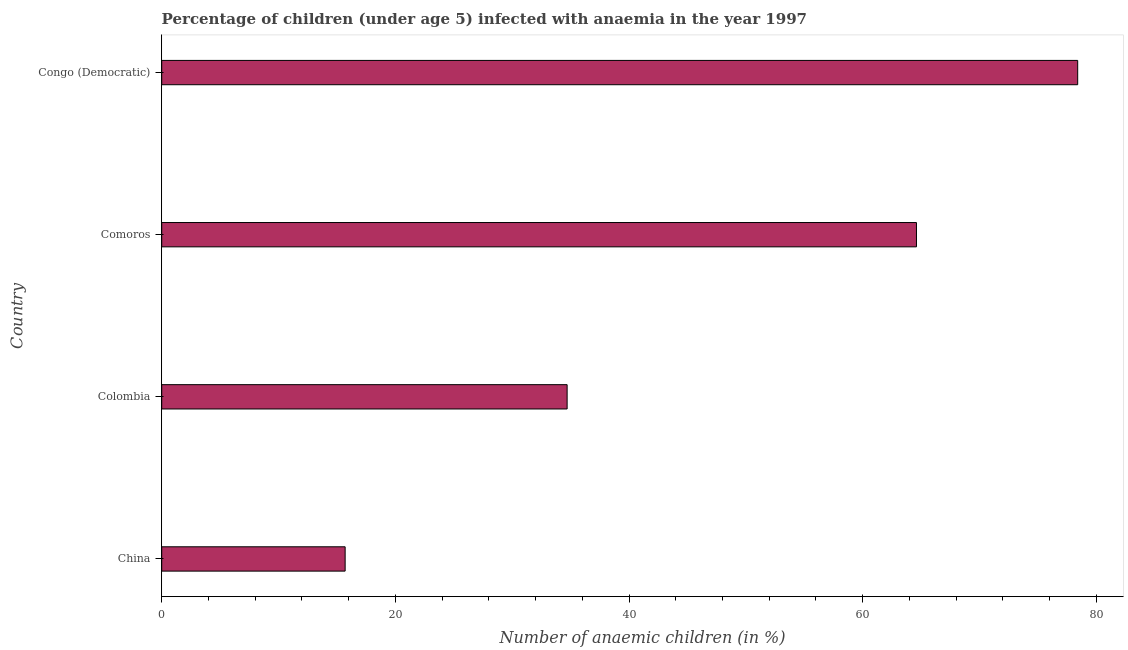Does the graph contain any zero values?
Keep it short and to the point. No. What is the title of the graph?
Make the answer very short. Percentage of children (under age 5) infected with anaemia in the year 1997. What is the label or title of the X-axis?
Your answer should be very brief. Number of anaemic children (in %). What is the number of anaemic children in Congo (Democratic)?
Make the answer very short. 78.4. Across all countries, what is the maximum number of anaemic children?
Offer a terse response. 78.4. Across all countries, what is the minimum number of anaemic children?
Give a very brief answer. 15.7. In which country was the number of anaemic children maximum?
Provide a short and direct response. Congo (Democratic). In which country was the number of anaemic children minimum?
Make the answer very short. China. What is the sum of the number of anaemic children?
Give a very brief answer. 193.4. What is the difference between the number of anaemic children in China and Congo (Democratic)?
Give a very brief answer. -62.7. What is the average number of anaemic children per country?
Give a very brief answer. 48.35. What is the median number of anaemic children?
Provide a short and direct response. 49.65. What is the ratio of the number of anaemic children in China to that in Colombia?
Make the answer very short. 0.45. Is the sum of the number of anaemic children in China and Comoros greater than the maximum number of anaemic children across all countries?
Offer a terse response. Yes. What is the difference between the highest and the lowest number of anaemic children?
Ensure brevity in your answer.  62.7. How many bars are there?
Keep it short and to the point. 4. Are all the bars in the graph horizontal?
Give a very brief answer. Yes. How many countries are there in the graph?
Provide a short and direct response. 4. What is the difference between two consecutive major ticks on the X-axis?
Provide a short and direct response. 20. Are the values on the major ticks of X-axis written in scientific E-notation?
Give a very brief answer. No. What is the Number of anaemic children (in %) in Colombia?
Ensure brevity in your answer.  34.7. What is the Number of anaemic children (in %) of Comoros?
Keep it short and to the point. 64.6. What is the Number of anaemic children (in %) in Congo (Democratic)?
Give a very brief answer. 78.4. What is the difference between the Number of anaemic children (in %) in China and Comoros?
Your answer should be very brief. -48.9. What is the difference between the Number of anaemic children (in %) in China and Congo (Democratic)?
Your response must be concise. -62.7. What is the difference between the Number of anaemic children (in %) in Colombia and Comoros?
Your answer should be compact. -29.9. What is the difference between the Number of anaemic children (in %) in Colombia and Congo (Democratic)?
Ensure brevity in your answer.  -43.7. What is the ratio of the Number of anaemic children (in %) in China to that in Colombia?
Provide a short and direct response. 0.45. What is the ratio of the Number of anaemic children (in %) in China to that in Comoros?
Your answer should be very brief. 0.24. What is the ratio of the Number of anaemic children (in %) in China to that in Congo (Democratic)?
Your answer should be very brief. 0.2. What is the ratio of the Number of anaemic children (in %) in Colombia to that in Comoros?
Provide a succinct answer. 0.54. What is the ratio of the Number of anaemic children (in %) in Colombia to that in Congo (Democratic)?
Keep it short and to the point. 0.44. What is the ratio of the Number of anaemic children (in %) in Comoros to that in Congo (Democratic)?
Make the answer very short. 0.82. 